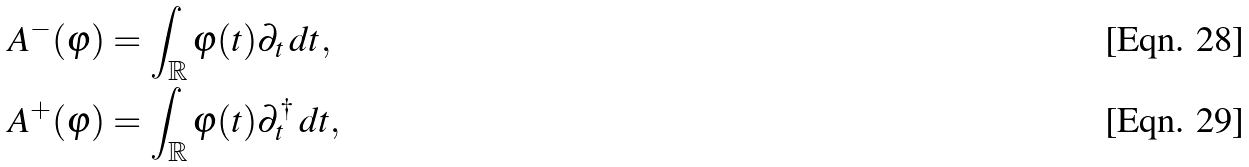Convert formula to latex. <formula><loc_0><loc_0><loc_500><loc_500>A ^ { - } ( \varphi ) & = \int _ { \mathbb { R } } \varphi ( t ) \partial _ { t } \, d t , \\ A ^ { + } ( \varphi ) & = \int _ { \mathbb { R } } \varphi ( t ) \partial _ { t } ^ { \dag } \, d t ,</formula> 